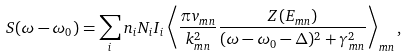<formula> <loc_0><loc_0><loc_500><loc_500>S ( \omega - \omega _ { 0 } ) = \sum _ { i } n _ { i } N _ { i } I _ { i } \left \langle \frac { \pi v _ { m n } } { k _ { m n } ^ { 2 } } \frac { Z ( E _ { m n } ) } { ( \omega - \omega _ { 0 } - \Delta ) ^ { 2 } + \gamma _ { m n } ^ { 2 } } \right \rangle _ { m n } ,</formula> 